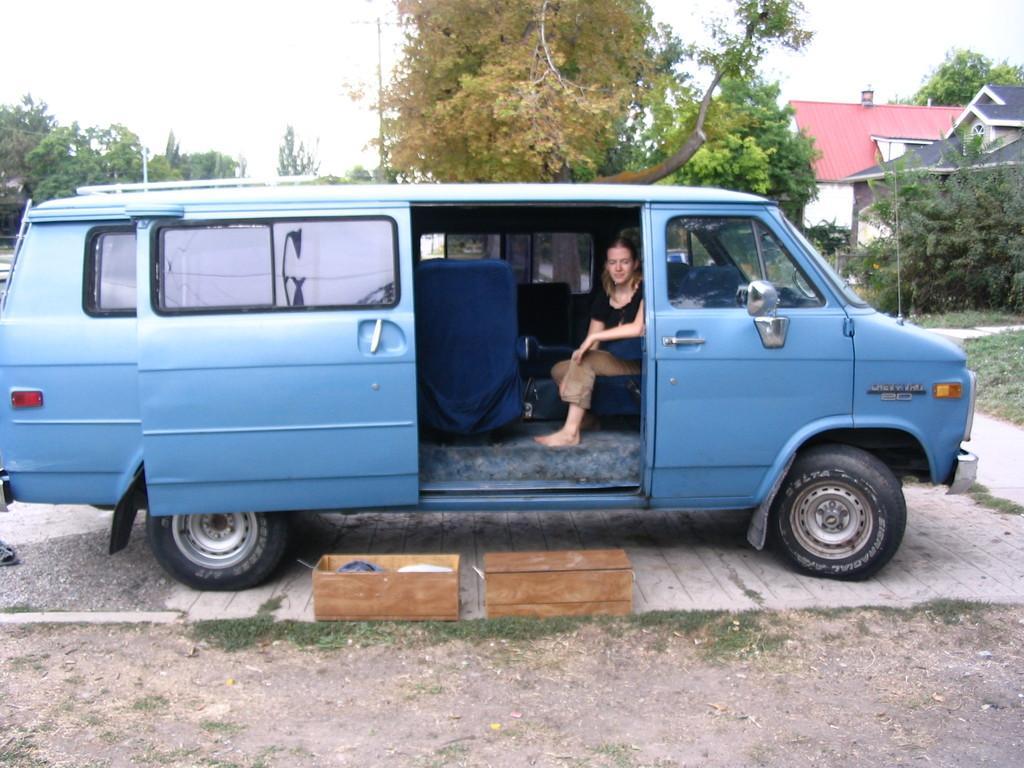Can you describe this image briefly? In this picture we can see a woman is seated in the car, and also we can find two boxes in front of her, in the background we can see couple of trees and buildings. 